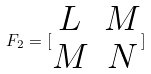<formula> <loc_0><loc_0><loc_500><loc_500>F _ { 2 } = [ \begin{matrix} L & M \\ M & N \end{matrix} ]</formula> 